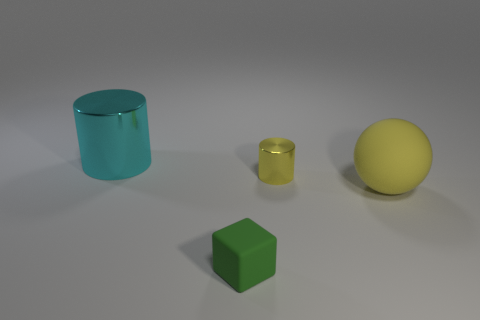Are there any yellow cylinders that have the same material as the block?
Provide a succinct answer. No. What number of things are either big cyan cylinders or small cyan blocks?
Make the answer very short. 1. Do the small green thing and the cylinder that is left of the small metallic cylinder have the same material?
Your answer should be compact. No. There is a green object in front of the tiny yellow cylinder; what is its size?
Your answer should be compact. Small. Is the number of small green matte objects less than the number of shiny things?
Make the answer very short. Yes. Are there any tiny metallic things of the same color as the big sphere?
Your answer should be very brief. Yes. What is the shape of the thing that is in front of the yellow cylinder and right of the tiny green rubber block?
Give a very brief answer. Sphere. What shape is the large thing behind the large thing in front of the big cyan metal thing?
Offer a terse response. Cylinder. Do the cyan metal thing and the tiny yellow shiny object have the same shape?
Provide a short and direct response. Yes. There is a thing that is the same color as the rubber sphere; what is it made of?
Your answer should be very brief. Metal. 